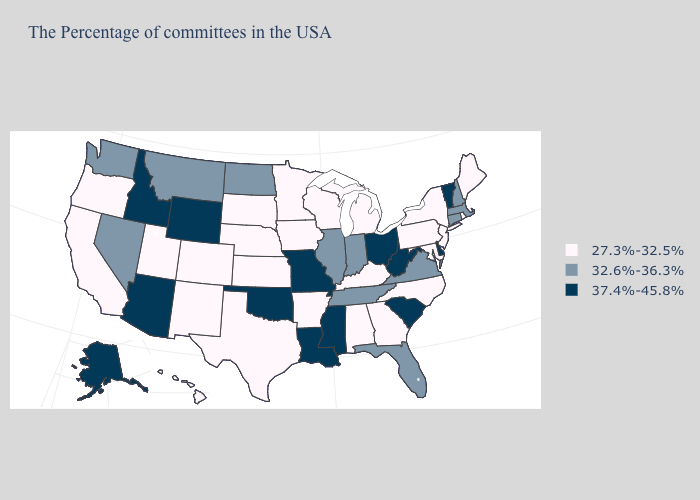What is the lowest value in the West?
Be succinct. 27.3%-32.5%. Does the first symbol in the legend represent the smallest category?
Quick response, please. Yes. Among the states that border West Virginia , which have the highest value?
Concise answer only. Ohio. What is the highest value in states that border Missouri?
Write a very short answer. 37.4%-45.8%. What is the value of Nevada?
Write a very short answer. 32.6%-36.3%. Does Delaware have the highest value in the South?
Short answer required. Yes. Is the legend a continuous bar?
Give a very brief answer. No. Does Maryland have the highest value in the South?
Concise answer only. No. Among the states that border Minnesota , does Wisconsin have the lowest value?
Be succinct. Yes. Among the states that border Minnesota , does North Dakota have the lowest value?
Short answer required. No. Does Oregon have the lowest value in the West?
Keep it brief. Yes. Name the states that have a value in the range 32.6%-36.3%?
Short answer required. Massachusetts, New Hampshire, Connecticut, Virginia, Florida, Indiana, Tennessee, Illinois, North Dakota, Montana, Nevada, Washington. Among the states that border Maryland , does Virginia have the lowest value?
Be succinct. No. Name the states that have a value in the range 37.4%-45.8%?
Quick response, please. Vermont, Delaware, South Carolina, West Virginia, Ohio, Mississippi, Louisiana, Missouri, Oklahoma, Wyoming, Arizona, Idaho, Alaska. What is the value of Massachusetts?
Short answer required. 32.6%-36.3%. 